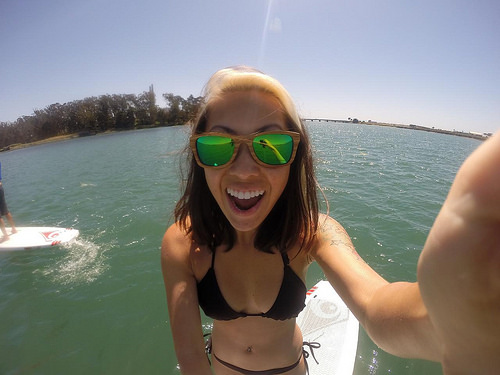<image>
Can you confirm if the girl is in the water? No. The girl is not contained within the water. These objects have a different spatial relationship. Is the woman in front of the sunglasses? No. The woman is not in front of the sunglasses. The spatial positioning shows a different relationship between these objects. 